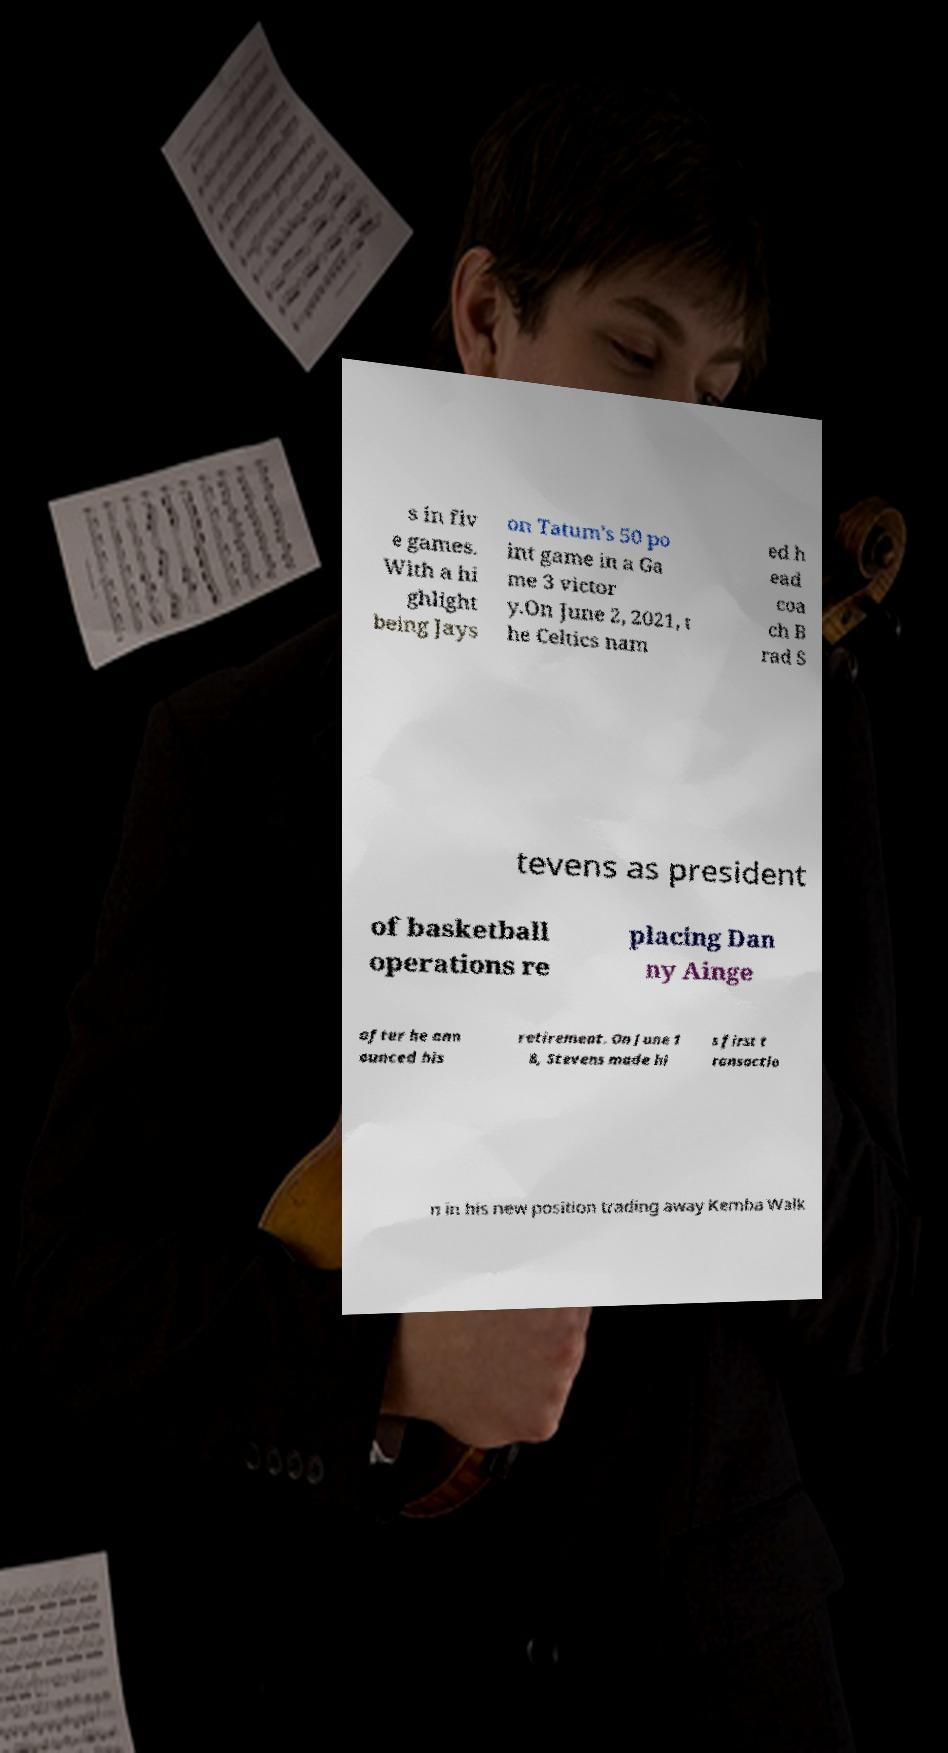What messages or text are displayed in this image? I need them in a readable, typed format. s in fiv e games. With a hi ghlight being Jays on Tatum's 50 po int game in a Ga me 3 victor y.On June 2, 2021, t he Celtics nam ed h ead coa ch B rad S tevens as president of basketball operations re placing Dan ny Ainge after he ann ounced his retirement. On June 1 8, Stevens made hi s first t ransactio n in his new position trading away Kemba Walk 